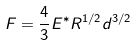Convert formula to latex. <formula><loc_0><loc_0><loc_500><loc_500>F = \frac { 4 } { 3 } E ^ { * } R ^ { 1 / 2 } d ^ { 3 / 2 }</formula> 